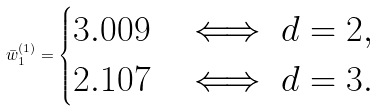<formula> <loc_0><loc_0><loc_500><loc_500>\bar { w } ^ { ( 1 ) } _ { 1 } = \begin{cases} 3 . 0 0 9 & \iff d = 2 , \\ 2 . 1 0 7 & \iff d = 3 . \end{cases}</formula> 